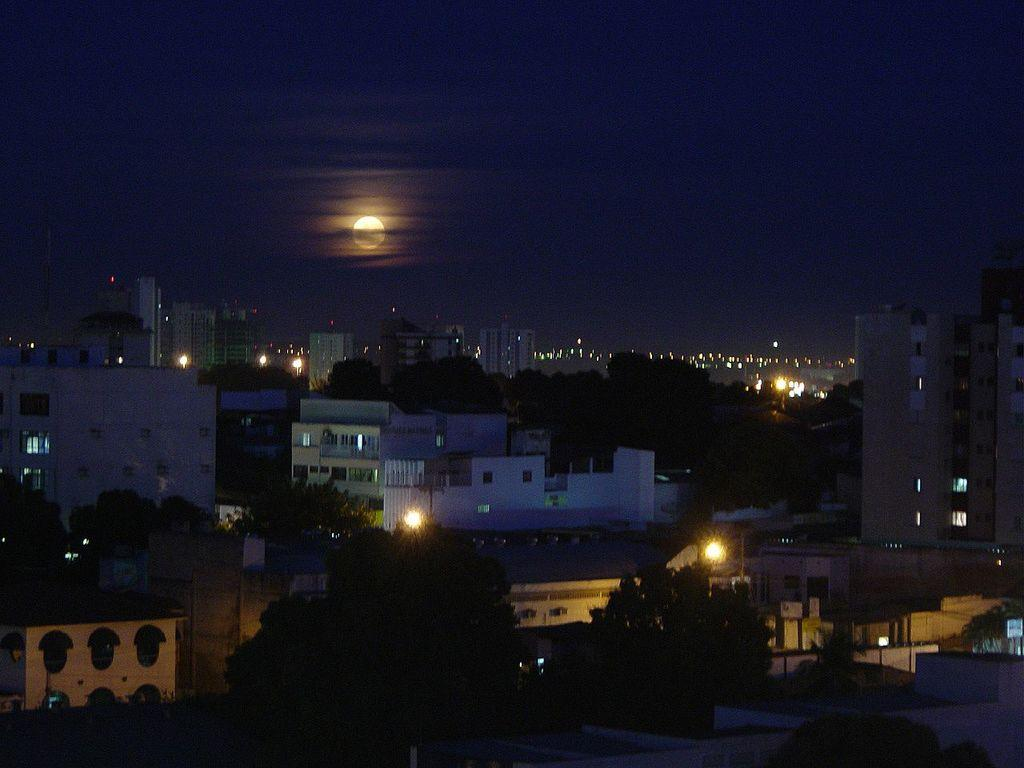What type of structures can be seen in the image? There are buildings in the image. What other natural elements are present in the image? There are trees in the image. Are there any artificial light sources visible in the image? Yes, there are lights in the image. What can be seen in the distance in the image? The sky is visible in the background of the image. What type of toys can be seen on the recess level in the image? There is no recess or toys present in the image; it features buildings, trees, lights, and the sky. 